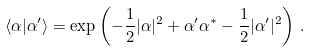Convert formula to latex. <formula><loc_0><loc_0><loc_500><loc_500>\langle \alpha | \alpha ^ { \prime } \rangle = \exp \left ( - \frac { 1 } { 2 } | \alpha | ^ { 2 } + \alpha ^ { \prime } \alpha ^ { * } - \frac { 1 } { 2 } | \alpha ^ { \prime } | ^ { 2 } \right ) \, .</formula> 